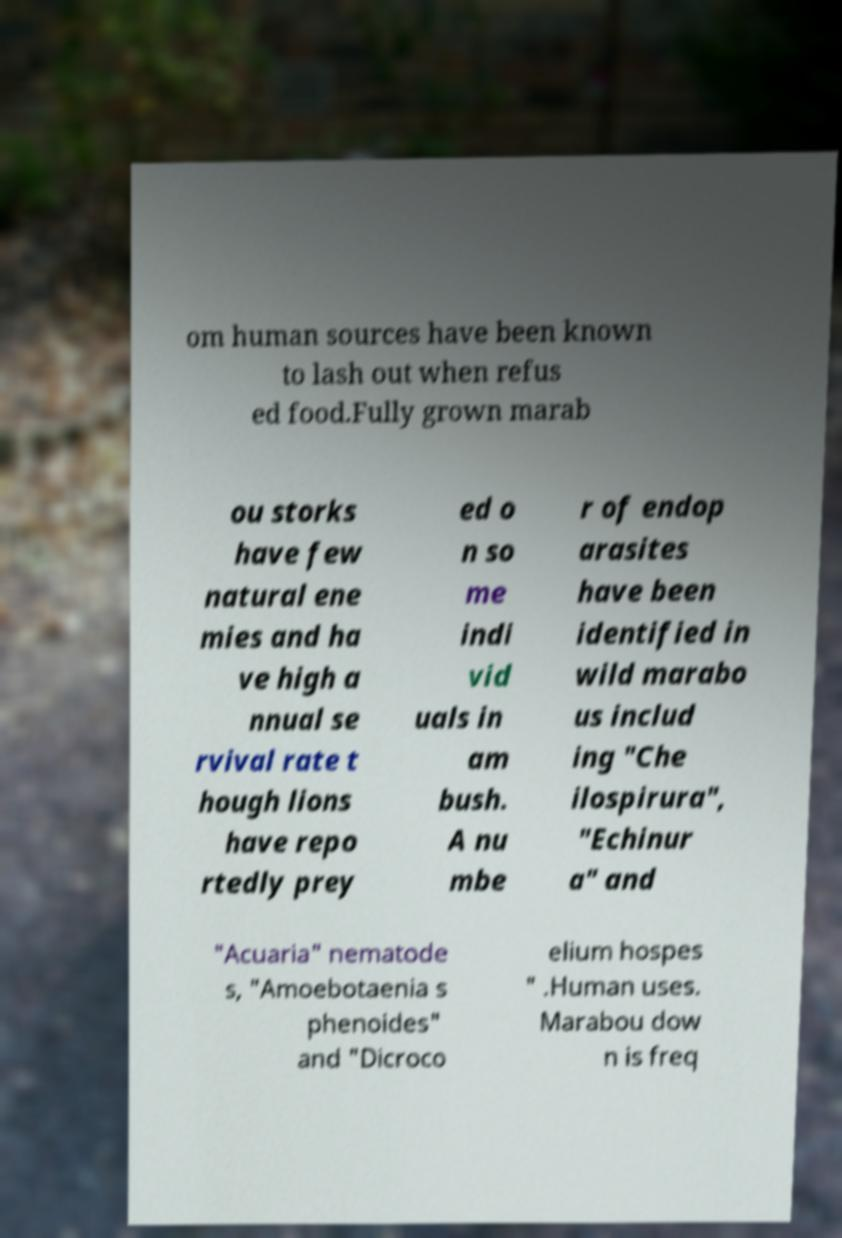I need the written content from this picture converted into text. Can you do that? om human sources have been known to lash out when refus ed food.Fully grown marab ou storks have few natural ene mies and ha ve high a nnual se rvival rate t hough lions have repo rtedly prey ed o n so me indi vid uals in am bush. A nu mbe r of endop arasites have been identified in wild marabo us includ ing "Che ilospirura", "Echinur a" and "Acuaria" nematode s, "Amoebotaenia s phenoides" and "Dicroco elium hospes " .Human uses. Marabou dow n is freq 